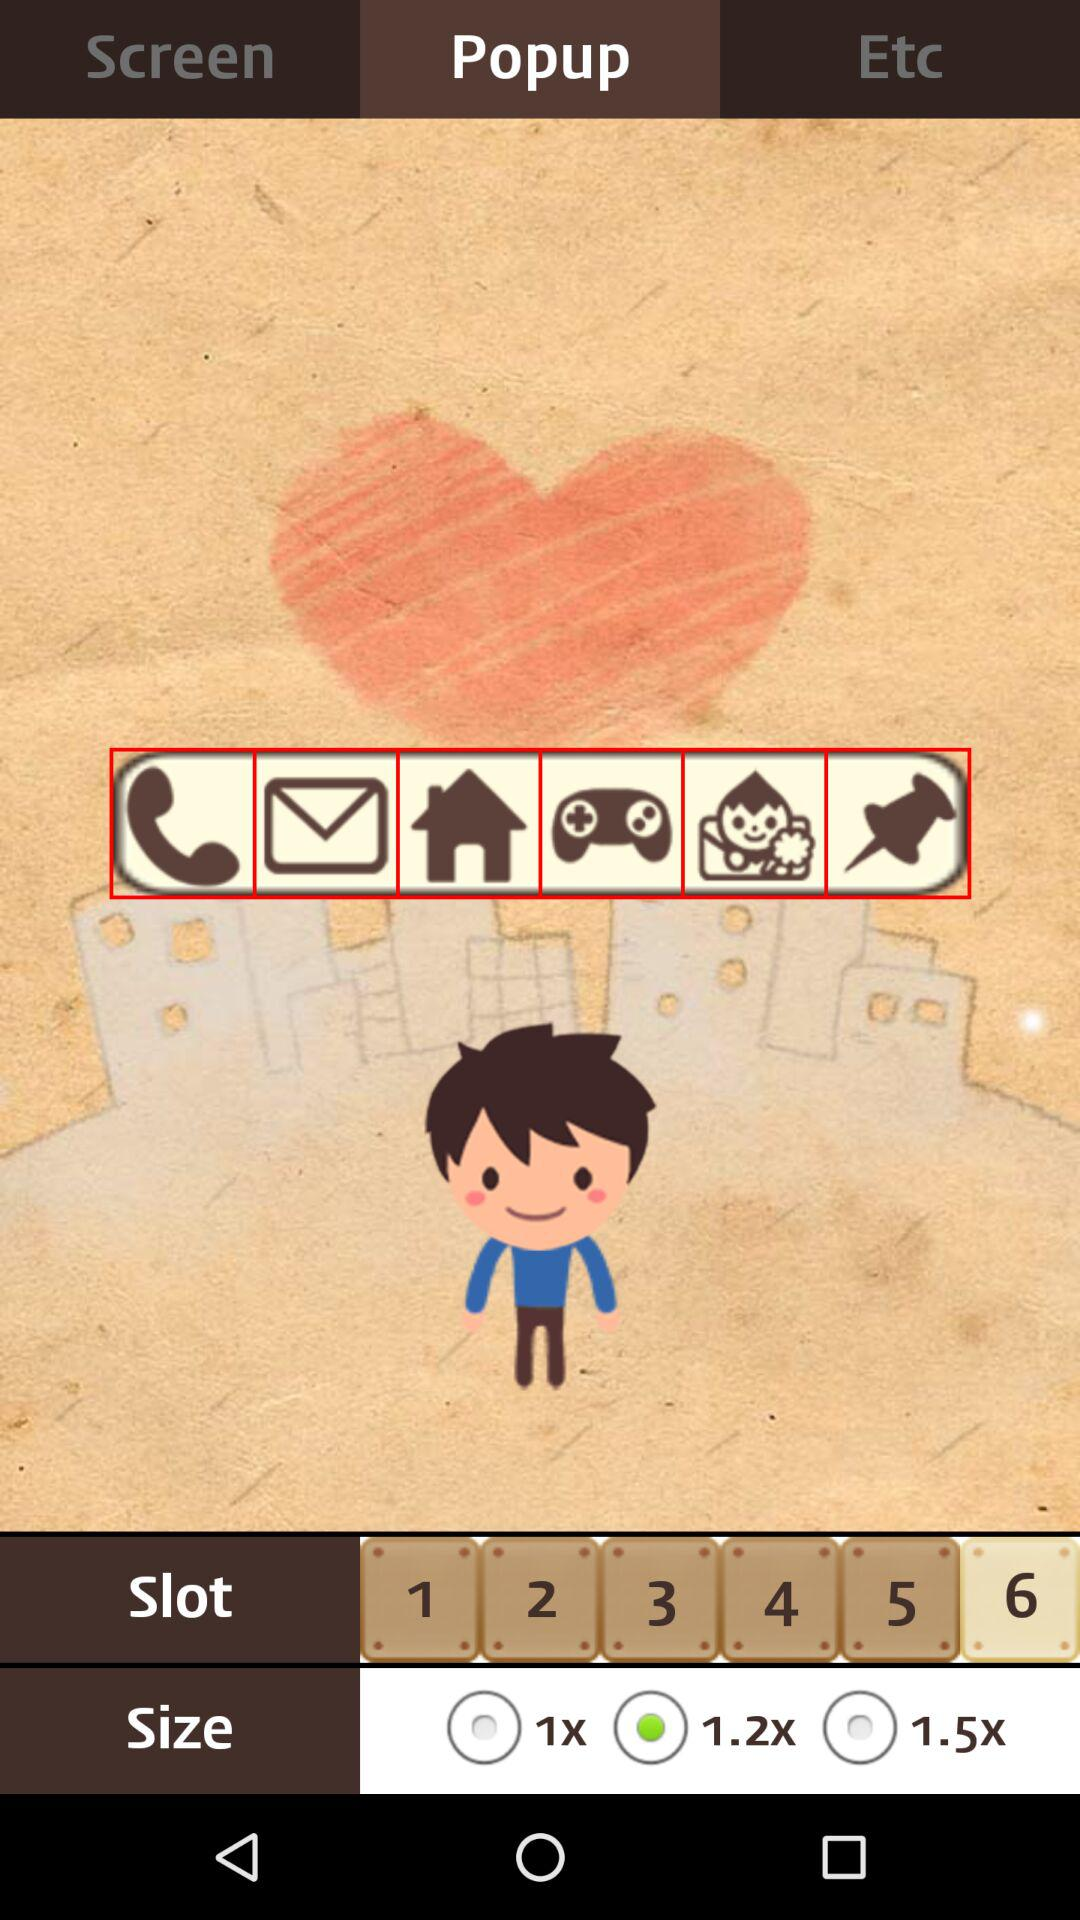How many different size options are there?
Answer the question using a single word or phrase. 3 